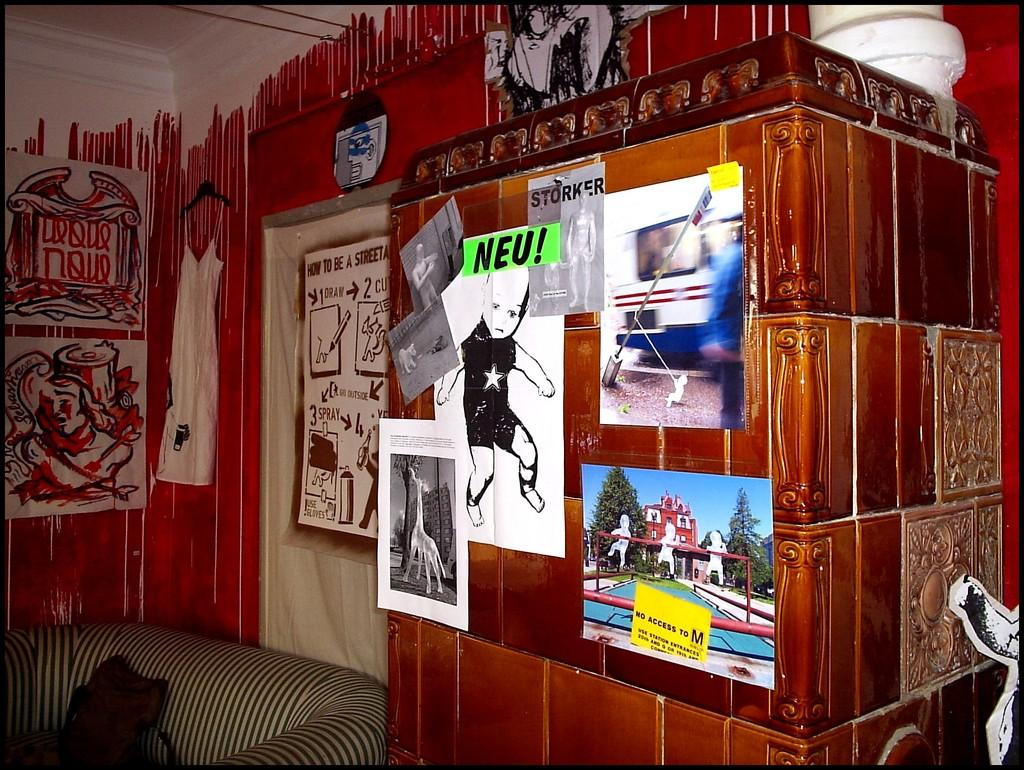Where was the image taken? The image was taken inside a room. What piece of furniture is on the left side of the image? There is a sofa on the left side of the image. What can be seen on the wall behind the sofa? The wall behind the sofa has paintings and pictures on it. Can you tell me what type of nut is being used as a bookmark in the image? There is no book or nut present in the image. How many goldfish are swimming in the bowl on the table in the image? There is no goldfish or bowl present in the image. 